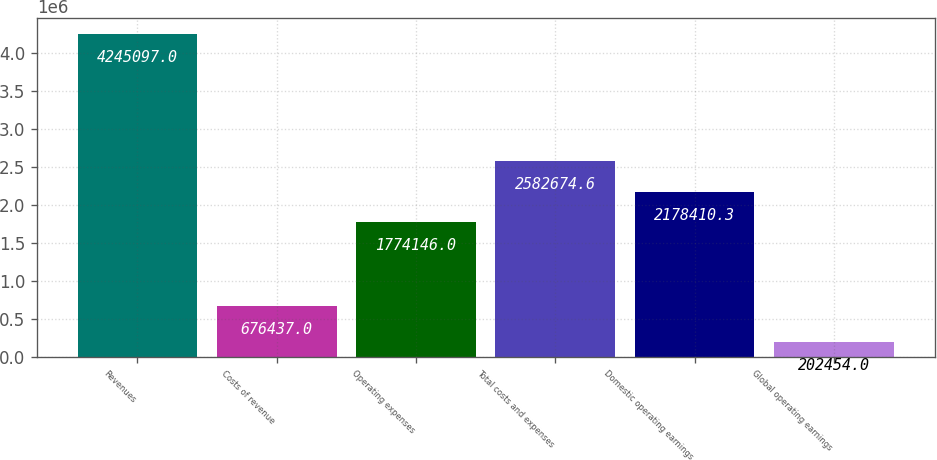<chart> <loc_0><loc_0><loc_500><loc_500><bar_chart><fcel>Revenues<fcel>Costs of revenue<fcel>Operating expenses<fcel>Total costs and expenses<fcel>Domestic operating earnings<fcel>Global operating earnings<nl><fcel>4.2451e+06<fcel>676437<fcel>1.77415e+06<fcel>2.58267e+06<fcel>2.17841e+06<fcel>202454<nl></chart> 